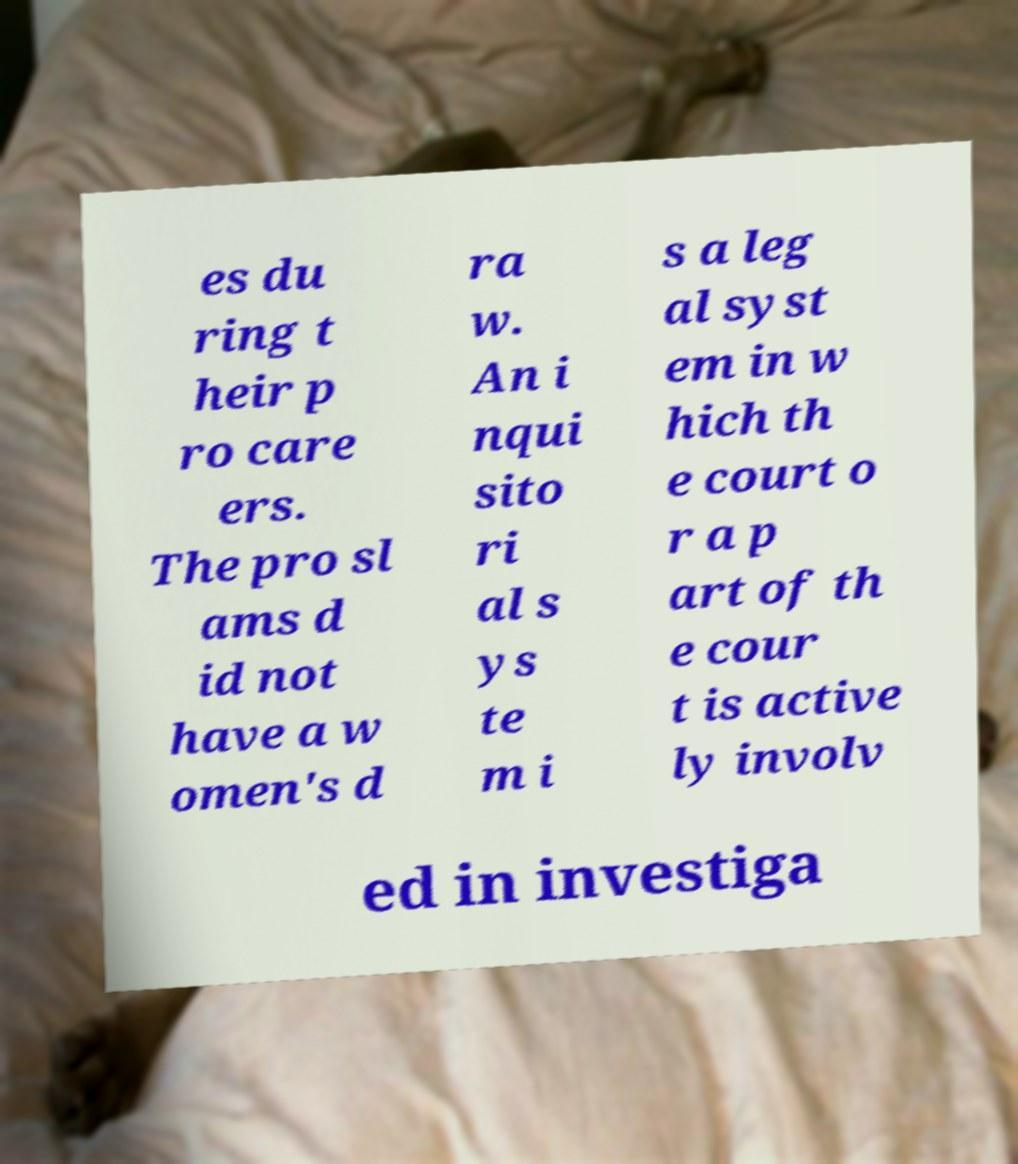For documentation purposes, I need the text within this image transcribed. Could you provide that? es du ring t heir p ro care ers. The pro sl ams d id not have a w omen's d ra w. An i nqui sito ri al s ys te m i s a leg al syst em in w hich th e court o r a p art of th e cour t is active ly involv ed in investiga 